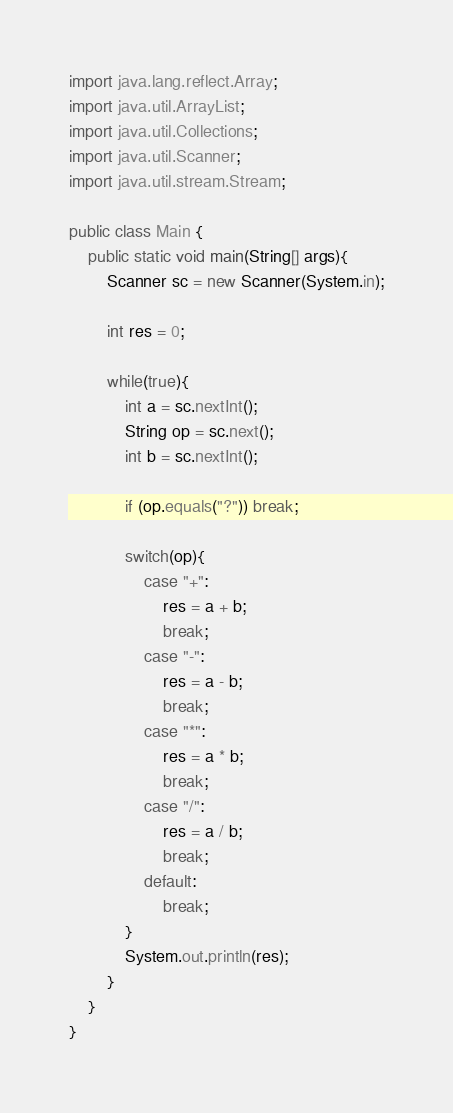Convert code to text. <code><loc_0><loc_0><loc_500><loc_500><_Java_>import java.lang.reflect.Array;
import java.util.ArrayList;
import java.util.Collections;
import java.util.Scanner;
import java.util.stream.Stream;

public class Main {
    public static void main(String[] args){
        Scanner sc = new Scanner(System.in);

        int res = 0;

        while(true){
            int a = sc.nextInt();
            String op = sc.next();
            int b = sc.nextInt();

            if (op.equals("?")) break;

            switch(op){
                case "+":
                    res = a + b;
                    break;
                case "-":
                    res = a - b;
                    break;
                case "*":
                    res = a * b;
                    break;
                case "/":
                    res = a / b;
                    break;
                default:
                    break;
            }
            System.out.println(res);
        }
    }
}

</code> 